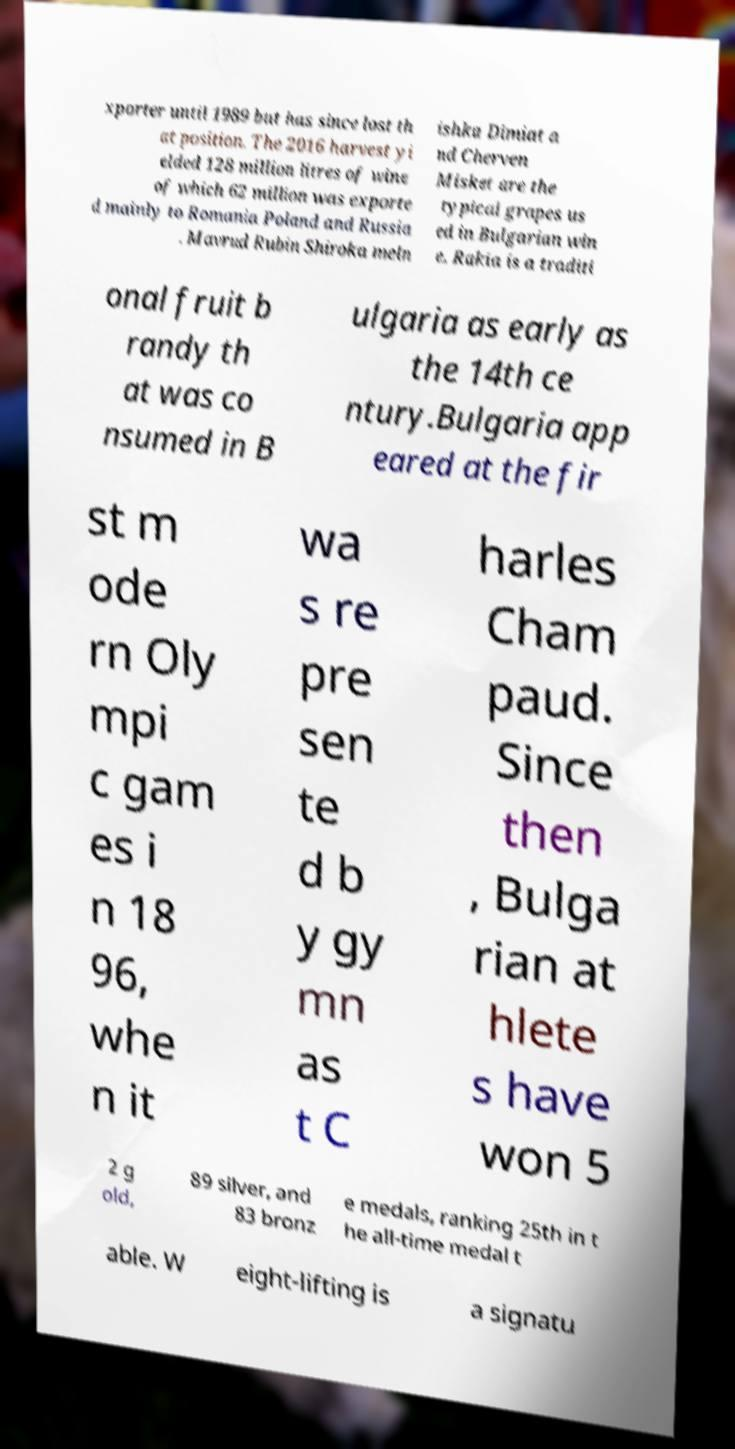For documentation purposes, I need the text within this image transcribed. Could you provide that? xporter until 1989 but has since lost th at position. The 2016 harvest yi elded 128 million litres of wine of which 62 million was exporte d mainly to Romania Poland and Russia . Mavrud Rubin Shiroka meln ishka Dimiat a nd Cherven Misket are the typical grapes us ed in Bulgarian win e. Rakia is a traditi onal fruit b randy th at was co nsumed in B ulgaria as early as the 14th ce ntury.Bulgaria app eared at the fir st m ode rn Oly mpi c gam es i n 18 96, whe n it wa s re pre sen te d b y gy mn as t C harles Cham paud. Since then , Bulga rian at hlete s have won 5 2 g old, 89 silver, and 83 bronz e medals, ranking 25th in t he all-time medal t able. W eight-lifting is a signatu 